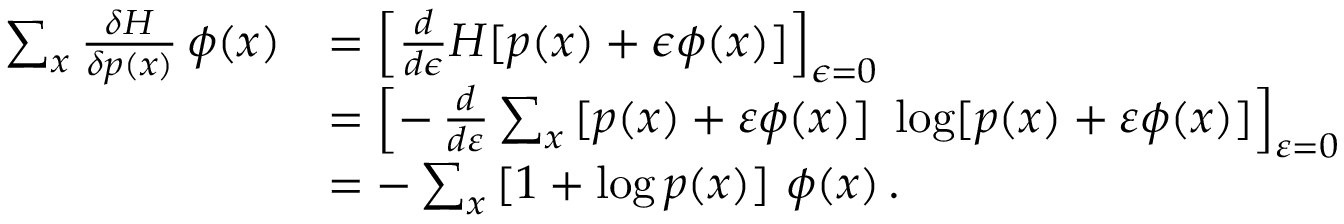<formula> <loc_0><loc_0><loc_500><loc_500>{ \begin{array} { r l } { \sum _ { x } { \frac { \delta H } { \delta p ( x ) } } \, \phi ( x ) } & { = \left [ { \frac { d } { d \epsilon } } H [ p ( x ) + \epsilon \phi ( x ) ] \right ] _ { \epsilon = 0 } } \\ & { = \left [ - \, { \frac { d } { d \varepsilon } } \sum _ { x } \, [ p ( x ) + \varepsilon \phi ( x ) ] \ \log [ p ( x ) + \varepsilon \phi ( x ) ] \right ] _ { \varepsilon = 0 } } \\ & { = - \sum _ { x } \, [ 1 + \log p ( x ) ] \ \phi ( x ) \, . } \end{array} }</formula> 